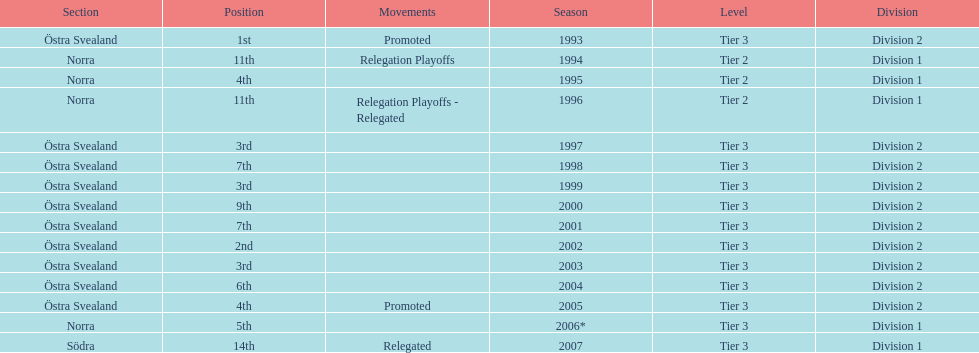They placed third in 2003. when did they place third before that? 1999. 